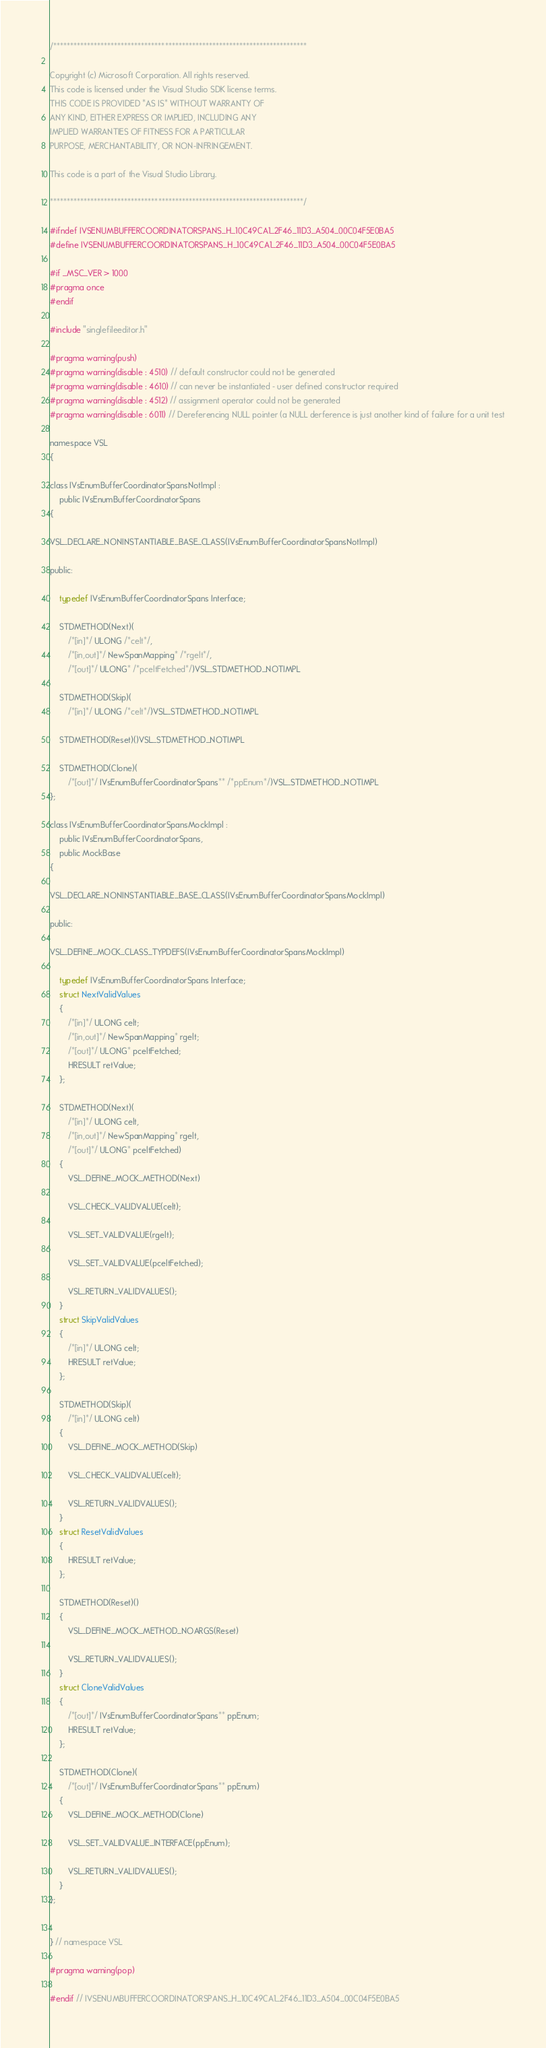<code> <loc_0><loc_0><loc_500><loc_500><_C_>/***************************************************************************

Copyright (c) Microsoft Corporation. All rights reserved.
This code is licensed under the Visual Studio SDK license terms.
THIS CODE IS PROVIDED *AS IS* WITHOUT WARRANTY OF
ANY KIND, EITHER EXPRESS OR IMPLIED, INCLUDING ANY
IMPLIED WARRANTIES OF FITNESS FOR A PARTICULAR
PURPOSE, MERCHANTABILITY, OR NON-INFRINGEMENT.

This code is a part of the Visual Studio Library.

***************************************************************************/

#ifndef IVSENUMBUFFERCOORDINATORSPANS_H_10C49CA1_2F46_11D3_A504_00C04F5E0BA5
#define IVSENUMBUFFERCOORDINATORSPANS_H_10C49CA1_2F46_11D3_A504_00C04F5E0BA5

#if _MSC_VER > 1000
#pragma once
#endif

#include "singlefileeditor.h"

#pragma warning(push)
#pragma warning(disable : 4510) // default constructor could not be generated
#pragma warning(disable : 4610) // can never be instantiated - user defined constructor required
#pragma warning(disable : 4512) // assignment operator could not be generated
#pragma warning(disable : 6011) // Dereferencing NULL pointer (a NULL derference is just another kind of failure for a unit test

namespace VSL
{

class IVsEnumBufferCoordinatorSpansNotImpl :
	public IVsEnumBufferCoordinatorSpans
{

VSL_DECLARE_NONINSTANTIABLE_BASE_CLASS(IVsEnumBufferCoordinatorSpansNotImpl)

public:

	typedef IVsEnumBufferCoordinatorSpans Interface;

	STDMETHOD(Next)(
		/*[in]*/ ULONG /*celt*/,
		/*[in,out]*/ NewSpanMapping* /*rgelt*/,
		/*[out]*/ ULONG* /*pceltFetched*/)VSL_STDMETHOD_NOTIMPL

	STDMETHOD(Skip)(
		/*[in]*/ ULONG /*celt*/)VSL_STDMETHOD_NOTIMPL

	STDMETHOD(Reset)()VSL_STDMETHOD_NOTIMPL

	STDMETHOD(Clone)(
		/*[out]*/ IVsEnumBufferCoordinatorSpans** /*ppEnum*/)VSL_STDMETHOD_NOTIMPL
};

class IVsEnumBufferCoordinatorSpansMockImpl :
	public IVsEnumBufferCoordinatorSpans,
	public MockBase
{

VSL_DECLARE_NONINSTANTIABLE_BASE_CLASS(IVsEnumBufferCoordinatorSpansMockImpl)

public:

VSL_DEFINE_MOCK_CLASS_TYPDEFS(IVsEnumBufferCoordinatorSpansMockImpl)

	typedef IVsEnumBufferCoordinatorSpans Interface;
	struct NextValidValues
	{
		/*[in]*/ ULONG celt;
		/*[in,out]*/ NewSpanMapping* rgelt;
		/*[out]*/ ULONG* pceltFetched;
		HRESULT retValue;
	};

	STDMETHOD(Next)(
		/*[in]*/ ULONG celt,
		/*[in,out]*/ NewSpanMapping* rgelt,
		/*[out]*/ ULONG* pceltFetched)
	{
		VSL_DEFINE_MOCK_METHOD(Next)

		VSL_CHECK_VALIDVALUE(celt);

		VSL_SET_VALIDVALUE(rgelt);

		VSL_SET_VALIDVALUE(pceltFetched);

		VSL_RETURN_VALIDVALUES();
	}
	struct SkipValidValues
	{
		/*[in]*/ ULONG celt;
		HRESULT retValue;
	};

	STDMETHOD(Skip)(
		/*[in]*/ ULONG celt)
	{
		VSL_DEFINE_MOCK_METHOD(Skip)

		VSL_CHECK_VALIDVALUE(celt);

		VSL_RETURN_VALIDVALUES();
	}
	struct ResetValidValues
	{
		HRESULT retValue;
	};

	STDMETHOD(Reset)()
	{
		VSL_DEFINE_MOCK_METHOD_NOARGS(Reset)

		VSL_RETURN_VALIDVALUES();
	}
	struct CloneValidValues
	{
		/*[out]*/ IVsEnumBufferCoordinatorSpans** ppEnum;
		HRESULT retValue;
	};

	STDMETHOD(Clone)(
		/*[out]*/ IVsEnumBufferCoordinatorSpans** ppEnum)
	{
		VSL_DEFINE_MOCK_METHOD(Clone)

		VSL_SET_VALIDVALUE_INTERFACE(ppEnum);

		VSL_RETURN_VALIDVALUES();
	}
};


} // namespace VSL

#pragma warning(pop)

#endif // IVSENUMBUFFERCOORDINATORSPANS_H_10C49CA1_2F46_11D3_A504_00C04F5E0BA5
</code> 